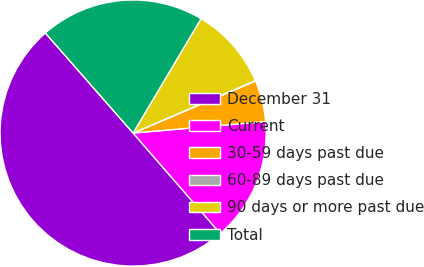<chart> <loc_0><loc_0><loc_500><loc_500><pie_chart><fcel>December 31<fcel>Current<fcel>30-59 days past due<fcel>60-89 days past due<fcel>90 days or more past due<fcel>Total<nl><fcel>49.92%<fcel>15.0%<fcel>5.03%<fcel>0.04%<fcel>10.02%<fcel>19.99%<nl></chart> 